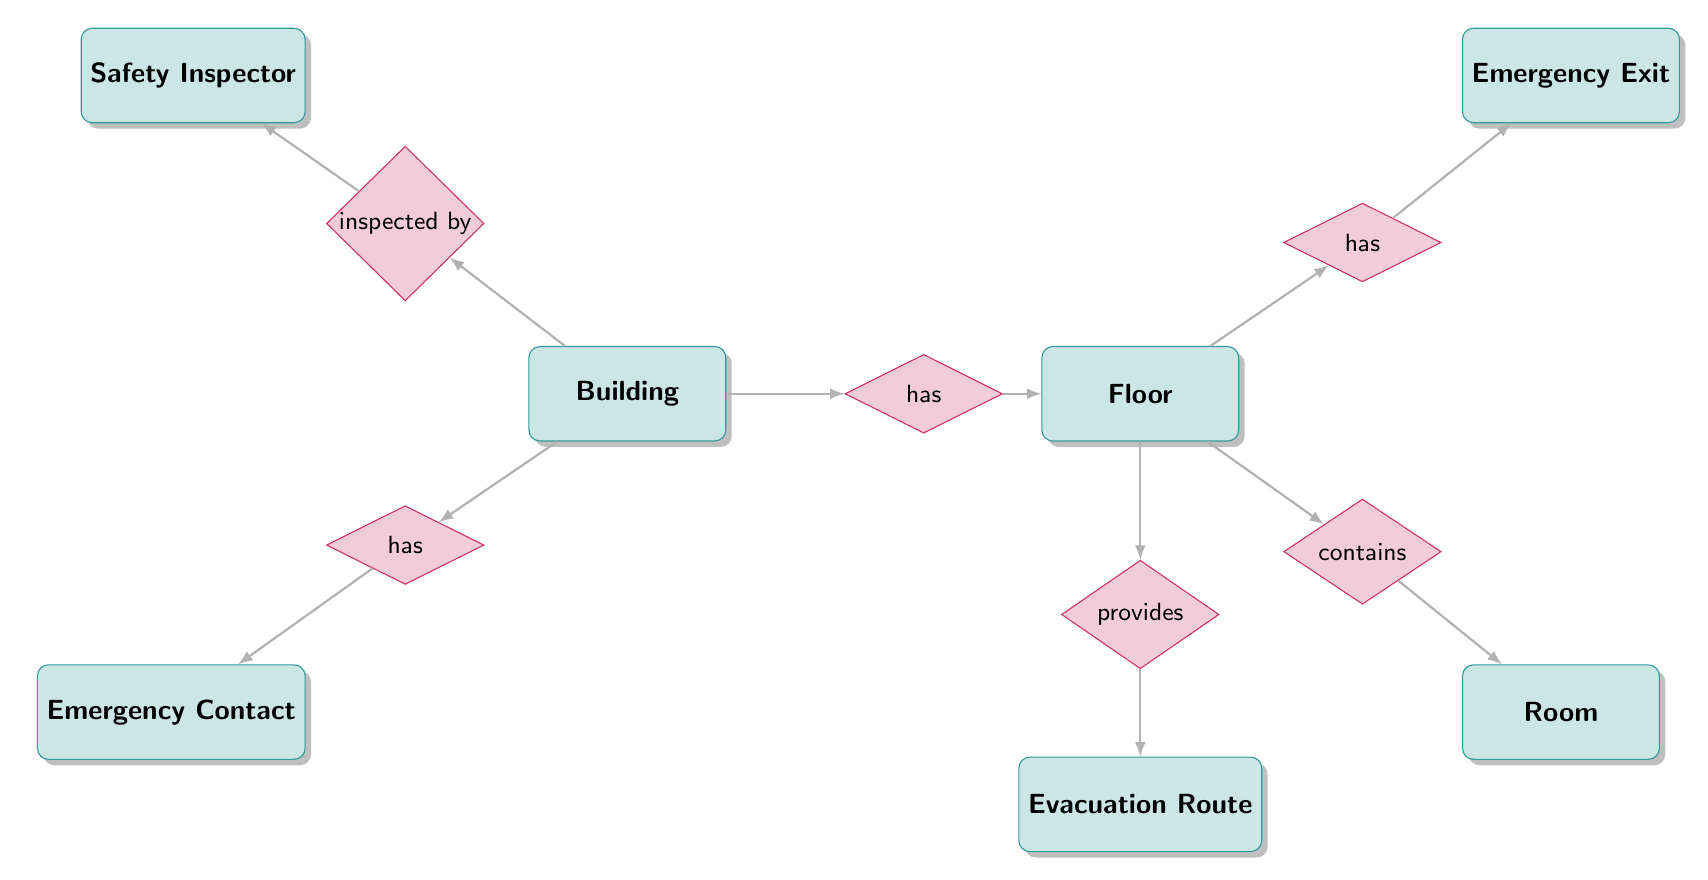What entity represents physical structures where rooms are contained? The entity "Building" represents the physical structures that encompass various rooms within them. It can be identified in the diagram as the primary entity and is connected to the "Floor" entity through the "has" relationship.
Answer: Building How many entities are present in the diagram? The diagram includes a total of seven entities: Building, Floor, Room, Emergency Exit, Evacuation Route, Emergency Contact, and Safety Inspector. This can be determined by counting each rectangle labeled in the diagram.
Answer: 7 What relationship connects a Floor to its Rooms? The relationship that connects a Floor to its Rooms is labeled as "contains." This indicates that within each Floor, there are various Rooms that are included or contained.
Answer: contains Which entity provides Evacuation Routes? The "Floor" entity provides the Evacuation Routes. This is shown by the "provides" relationship that links the Floor to the Evacuation Route entity.
Answer: Floor What type of contact is associated with the Building? The type of contact associated with the Building is "Emergency Contact." The diagram illustrates a "has" relationship linking the Building to the Emergency Contact entity, indicating that each Building should have designated emergency contacts.
Answer: Emergency Contact Which entity has the "inspected by" relationship with Building? The "Safety Inspector" entity has the "inspected by" relationship with the Building. This establishes that each Building is subjected to inspections by certified safety inspectors, as represented in the diagram.
Answer: Safety Inspector What is the maximum number of Emergency Exits that a Floor can have according to the diagram? The diagram does not specify a maximum number for Emergency Exits. However, each Floor has at least one Emergency Exit, as indicated by the "has" relationship from Floor to Emergency Exit.
Answer: Not specified What does the Evacuation Route connect? The Evacuation Route connects a "start location" to an "end location." This is detailed in the attributes of the Evacuation Route entity, which notes both the starting point and the destination area for evacuation.
Answer: start location, end location 